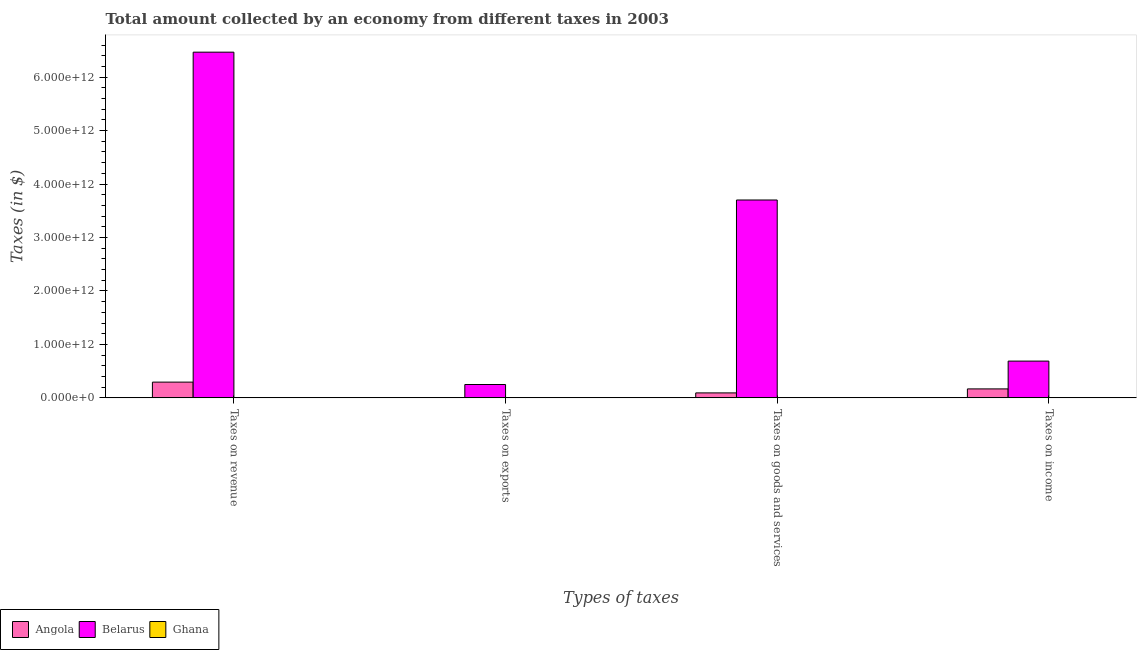How many different coloured bars are there?
Provide a short and direct response. 3. How many groups of bars are there?
Provide a succinct answer. 4. Are the number of bars per tick equal to the number of legend labels?
Provide a short and direct response. Yes. How many bars are there on the 2nd tick from the left?
Ensure brevity in your answer.  3. How many bars are there on the 4th tick from the right?
Offer a terse response. 3. What is the label of the 1st group of bars from the left?
Keep it short and to the point. Taxes on revenue. What is the amount collected as tax on goods in Angola?
Offer a terse response. 9.31e+1. Across all countries, what is the maximum amount collected as tax on income?
Your response must be concise. 6.88e+11. Across all countries, what is the minimum amount collected as tax on exports?
Keep it short and to the point. 7.92e+07. In which country was the amount collected as tax on income maximum?
Your answer should be very brief. Belarus. What is the total amount collected as tax on exports in the graph?
Provide a succinct answer. 2.51e+11. What is the difference between the amount collected as tax on income in Angola and that in Ghana?
Your answer should be very brief. 1.67e+11. What is the difference between the amount collected as tax on income in Belarus and the amount collected as tax on goods in Angola?
Provide a succinct answer. 5.95e+11. What is the average amount collected as tax on income per country?
Give a very brief answer. 2.85e+11. What is the difference between the amount collected as tax on income and amount collected as tax on revenue in Ghana?
Give a very brief answer. -8.66e+08. In how many countries, is the amount collected as tax on exports greater than 4400000000000 $?
Your answer should be compact. 0. What is the ratio of the amount collected as tax on exports in Ghana to that in Angola?
Provide a succinct answer. 0.19. What is the difference between the highest and the second highest amount collected as tax on exports?
Your response must be concise. 2.50e+11. What is the difference between the highest and the lowest amount collected as tax on goods?
Provide a succinct answer. 3.70e+12. In how many countries, is the amount collected as tax on exports greater than the average amount collected as tax on exports taken over all countries?
Offer a terse response. 1. Is the sum of the amount collected as tax on goods in Belarus and Angola greater than the maximum amount collected as tax on exports across all countries?
Ensure brevity in your answer.  Yes. Is it the case that in every country, the sum of the amount collected as tax on revenue and amount collected as tax on income is greater than the sum of amount collected as tax on exports and amount collected as tax on goods?
Your answer should be very brief. No. What does the 1st bar from the left in Taxes on exports represents?
Keep it short and to the point. Angola. What does the 3rd bar from the right in Taxes on goods and services represents?
Keep it short and to the point. Angola. Is it the case that in every country, the sum of the amount collected as tax on revenue and amount collected as tax on exports is greater than the amount collected as tax on goods?
Ensure brevity in your answer.  Yes. How many bars are there?
Offer a very short reply. 12. What is the difference between two consecutive major ticks on the Y-axis?
Give a very brief answer. 1.00e+12. Does the graph contain any zero values?
Offer a very short reply. No. How are the legend labels stacked?
Make the answer very short. Horizontal. What is the title of the graph?
Your response must be concise. Total amount collected by an economy from different taxes in 2003. Does "Lower middle income" appear as one of the legend labels in the graph?
Give a very brief answer. No. What is the label or title of the X-axis?
Give a very brief answer. Types of taxes. What is the label or title of the Y-axis?
Provide a succinct answer. Taxes (in $). What is the Taxes (in $) of Angola in Taxes on revenue?
Offer a very short reply. 2.95e+11. What is the Taxes (in $) in Belarus in Taxes on revenue?
Offer a very short reply. 6.47e+12. What is the Taxes (in $) of Ghana in Taxes on revenue?
Give a very brief answer. 1.22e+09. What is the Taxes (in $) of Angola in Taxes on exports?
Make the answer very short. 4.24e+08. What is the Taxes (in $) of Belarus in Taxes on exports?
Provide a succinct answer. 2.50e+11. What is the Taxes (in $) of Ghana in Taxes on exports?
Make the answer very short. 7.92e+07. What is the Taxes (in $) in Angola in Taxes on goods and services?
Offer a very short reply. 9.31e+1. What is the Taxes (in $) of Belarus in Taxes on goods and services?
Offer a very short reply. 3.70e+12. What is the Taxes (in $) of Ghana in Taxes on goods and services?
Your answer should be compact. 5.50e+08. What is the Taxes (in $) of Angola in Taxes on income?
Provide a succinct answer. 1.68e+11. What is the Taxes (in $) in Belarus in Taxes on income?
Make the answer very short. 6.88e+11. What is the Taxes (in $) in Ghana in Taxes on income?
Keep it short and to the point. 3.57e+08. Across all Types of taxes, what is the maximum Taxes (in $) in Angola?
Give a very brief answer. 2.95e+11. Across all Types of taxes, what is the maximum Taxes (in $) of Belarus?
Give a very brief answer. 6.47e+12. Across all Types of taxes, what is the maximum Taxes (in $) of Ghana?
Your response must be concise. 1.22e+09. Across all Types of taxes, what is the minimum Taxes (in $) of Angola?
Offer a very short reply. 4.24e+08. Across all Types of taxes, what is the minimum Taxes (in $) in Belarus?
Keep it short and to the point. 2.50e+11. Across all Types of taxes, what is the minimum Taxes (in $) of Ghana?
Ensure brevity in your answer.  7.92e+07. What is the total Taxes (in $) of Angola in the graph?
Make the answer very short. 5.56e+11. What is the total Taxes (in $) of Belarus in the graph?
Your response must be concise. 1.11e+13. What is the total Taxes (in $) in Ghana in the graph?
Make the answer very short. 2.21e+09. What is the difference between the Taxes (in $) in Angola in Taxes on revenue and that in Taxes on exports?
Offer a terse response. 2.94e+11. What is the difference between the Taxes (in $) of Belarus in Taxes on revenue and that in Taxes on exports?
Provide a succinct answer. 6.22e+12. What is the difference between the Taxes (in $) of Ghana in Taxes on revenue and that in Taxes on exports?
Provide a succinct answer. 1.14e+09. What is the difference between the Taxes (in $) in Angola in Taxes on revenue and that in Taxes on goods and services?
Make the answer very short. 2.01e+11. What is the difference between the Taxes (in $) in Belarus in Taxes on revenue and that in Taxes on goods and services?
Provide a short and direct response. 2.77e+12. What is the difference between the Taxes (in $) of Ghana in Taxes on revenue and that in Taxes on goods and services?
Make the answer very short. 6.73e+08. What is the difference between the Taxes (in $) of Angola in Taxes on revenue and that in Taxes on income?
Keep it short and to the point. 1.27e+11. What is the difference between the Taxes (in $) in Belarus in Taxes on revenue and that in Taxes on income?
Ensure brevity in your answer.  5.78e+12. What is the difference between the Taxes (in $) in Ghana in Taxes on revenue and that in Taxes on income?
Give a very brief answer. 8.66e+08. What is the difference between the Taxes (in $) of Angola in Taxes on exports and that in Taxes on goods and services?
Make the answer very short. -9.27e+1. What is the difference between the Taxes (in $) of Belarus in Taxes on exports and that in Taxes on goods and services?
Provide a succinct answer. -3.45e+12. What is the difference between the Taxes (in $) in Ghana in Taxes on exports and that in Taxes on goods and services?
Your answer should be compact. -4.70e+08. What is the difference between the Taxes (in $) in Angola in Taxes on exports and that in Taxes on income?
Provide a short and direct response. -1.67e+11. What is the difference between the Taxes (in $) of Belarus in Taxes on exports and that in Taxes on income?
Offer a very short reply. -4.38e+11. What is the difference between the Taxes (in $) of Ghana in Taxes on exports and that in Taxes on income?
Ensure brevity in your answer.  -2.78e+08. What is the difference between the Taxes (in $) of Angola in Taxes on goods and services and that in Taxes on income?
Give a very brief answer. -7.46e+1. What is the difference between the Taxes (in $) of Belarus in Taxes on goods and services and that in Taxes on income?
Your answer should be very brief. 3.01e+12. What is the difference between the Taxes (in $) in Ghana in Taxes on goods and services and that in Taxes on income?
Provide a short and direct response. 1.93e+08. What is the difference between the Taxes (in $) in Angola in Taxes on revenue and the Taxes (in $) in Belarus in Taxes on exports?
Ensure brevity in your answer.  4.45e+1. What is the difference between the Taxes (in $) of Angola in Taxes on revenue and the Taxes (in $) of Ghana in Taxes on exports?
Ensure brevity in your answer.  2.95e+11. What is the difference between the Taxes (in $) in Belarus in Taxes on revenue and the Taxes (in $) in Ghana in Taxes on exports?
Offer a very short reply. 6.47e+12. What is the difference between the Taxes (in $) in Angola in Taxes on revenue and the Taxes (in $) in Belarus in Taxes on goods and services?
Keep it short and to the point. -3.41e+12. What is the difference between the Taxes (in $) in Angola in Taxes on revenue and the Taxes (in $) in Ghana in Taxes on goods and services?
Ensure brevity in your answer.  2.94e+11. What is the difference between the Taxes (in $) of Belarus in Taxes on revenue and the Taxes (in $) of Ghana in Taxes on goods and services?
Offer a terse response. 6.47e+12. What is the difference between the Taxes (in $) of Angola in Taxes on revenue and the Taxes (in $) of Belarus in Taxes on income?
Your answer should be very brief. -3.93e+11. What is the difference between the Taxes (in $) of Angola in Taxes on revenue and the Taxes (in $) of Ghana in Taxes on income?
Ensure brevity in your answer.  2.94e+11. What is the difference between the Taxes (in $) in Belarus in Taxes on revenue and the Taxes (in $) in Ghana in Taxes on income?
Keep it short and to the point. 6.47e+12. What is the difference between the Taxes (in $) in Angola in Taxes on exports and the Taxes (in $) in Belarus in Taxes on goods and services?
Your response must be concise. -3.70e+12. What is the difference between the Taxes (in $) of Angola in Taxes on exports and the Taxes (in $) of Ghana in Taxes on goods and services?
Provide a short and direct response. -1.26e+08. What is the difference between the Taxes (in $) of Belarus in Taxes on exports and the Taxes (in $) of Ghana in Taxes on goods and services?
Provide a succinct answer. 2.50e+11. What is the difference between the Taxes (in $) in Angola in Taxes on exports and the Taxes (in $) in Belarus in Taxes on income?
Offer a very short reply. -6.87e+11. What is the difference between the Taxes (in $) of Angola in Taxes on exports and the Taxes (in $) of Ghana in Taxes on income?
Your answer should be compact. 6.68e+07. What is the difference between the Taxes (in $) of Belarus in Taxes on exports and the Taxes (in $) of Ghana in Taxes on income?
Ensure brevity in your answer.  2.50e+11. What is the difference between the Taxes (in $) in Angola in Taxes on goods and services and the Taxes (in $) in Belarus in Taxes on income?
Provide a succinct answer. -5.95e+11. What is the difference between the Taxes (in $) in Angola in Taxes on goods and services and the Taxes (in $) in Ghana in Taxes on income?
Provide a succinct answer. 9.28e+1. What is the difference between the Taxes (in $) in Belarus in Taxes on goods and services and the Taxes (in $) in Ghana in Taxes on income?
Provide a succinct answer. 3.70e+12. What is the average Taxes (in $) of Angola per Types of taxes?
Keep it short and to the point. 1.39e+11. What is the average Taxes (in $) in Belarus per Types of taxes?
Offer a very short reply. 2.78e+12. What is the average Taxes (in $) in Ghana per Types of taxes?
Give a very brief answer. 5.52e+08. What is the difference between the Taxes (in $) of Angola and Taxes (in $) of Belarus in Taxes on revenue?
Make the answer very short. -6.17e+12. What is the difference between the Taxes (in $) in Angola and Taxes (in $) in Ghana in Taxes on revenue?
Your response must be concise. 2.93e+11. What is the difference between the Taxes (in $) of Belarus and Taxes (in $) of Ghana in Taxes on revenue?
Give a very brief answer. 6.47e+12. What is the difference between the Taxes (in $) in Angola and Taxes (in $) in Belarus in Taxes on exports?
Your response must be concise. -2.50e+11. What is the difference between the Taxes (in $) in Angola and Taxes (in $) in Ghana in Taxes on exports?
Your answer should be very brief. 3.44e+08. What is the difference between the Taxes (in $) in Belarus and Taxes (in $) in Ghana in Taxes on exports?
Provide a short and direct response. 2.50e+11. What is the difference between the Taxes (in $) in Angola and Taxes (in $) in Belarus in Taxes on goods and services?
Give a very brief answer. -3.61e+12. What is the difference between the Taxes (in $) of Angola and Taxes (in $) of Ghana in Taxes on goods and services?
Provide a succinct answer. 9.26e+1. What is the difference between the Taxes (in $) in Belarus and Taxes (in $) in Ghana in Taxes on goods and services?
Your answer should be very brief. 3.70e+12. What is the difference between the Taxes (in $) of Angola and Taxes (in $) of Belarus in Taxes on income?
Ensure brevity in your answer.  -5.20e+11. What is the difference between the Taxes (in $) in Angola and Taxes (in $) in Ghana in Taxes on income?
Keep it short and to the point. 1.67e+11. What is the difference between the Taxes (in $) of Belarus and Taxes (in $) of Ghana in Taxes on income?
Give a very brief answer. 6.87e+11. What is the ratio of the Taxes (in $) of Angola in Taxes on revenue to that in Taxes on exports?
Offer a terse response. 695.46. What is the ratio of the Taxes (in $) in Belarus in Taxes on revenue to that in Taxes on exports?
Your answer should be very brief. 25.86. What is the ratio of the Taxes (in $) in Ghana in Taxes on revenue to that in Taxes on exports?
Your response must be concise. 15.43. What is the ratio of the Taxes (in $) in Angola in Taxes on revenue to that in Taxes on goods and services?
Offer a terse response. 3.16. What is the ratio of the Taxes (in $) of Belarus in Taxes on revenue to that in Taxes on goods and services?
Your answer should be very brief. 1.75. What is the ratio of the Taxes (in $) of Ghana in Taxes on revenue to that in Taxes on goods and services?
Provide a succinct answer. 2.22. What is the ratio of the Taxes (in $) in Angola in Taxes on revenue to that in Taxes on income?
Provide a short and direct response. 1.76. What is the ratio of the Taxes (in $) of Belarus in Taxes on revenue to that in Taxes on income?
Your answer should be very brief. 9.4. What is the ratio of the Taxes (in $) of Ghana in Taxes on revenue to that in Taxes on income?
Offer a very short reply. 3.43. What is the ratio of the Taxes (in $) in Angola in Taxes on exports to that in Taxes on goods and services?
Offer a very short reply. 0. What is the ratio of the Taxes (in $) of Belarus in Taxes on exports to that in Taxes on goods and services?
Ensure brevity in your answer.  0.07. What is the ratio of the Taxes (in $) in Ghana in Taxes on exports to that in Taxes on goods and services?
Ensure brevity in your answer.  0.14. What is the ratio of the Taxes (in $) of Angola in Taxes on exports to that in Taxes on income?
Provide a short and direct response. 0. What is the ratio of the Taxes (in $) in Belarus in Taxes on exports to that in Taxes on income?
Ensure brevity in your answer.  0.36. What is the ratio of the Taxes (in $) in Ghana in Taxes on exports to that in Taxes on income?
Offer a terse response. 0.22. What is the ratio of the Taxes (in $) of Angola in Taxes on goods and services to that in Taxes on income?
Make the answer very short. 0.56. What is the ratio of the Taxes (in $) in Belarus in Taxes on goods and services to that in Taxes on income?
Keep it short and to the point. 5.38. What is the ratio of the Taxes (in $) of Ghana in Taxes on goods and services to that in Taxes on income?
Your answer should be compact. 1.54. What is the difference between the highest and the second highest Taxes (in $) in Angola?
Your response must be concise. 1.27e+11. What is the difference between the highest and the second highest Taxes (in $) of Belarus?
Your response must be concise. 2.77e+12. What is the difference between the highest and the second highest Taxes (in $) in Ghana?
Offer a terse response. 6.73e+08. What is the difference between the highest and the lowest Taxes (in $) of Angola?
Ensure brevity in your answer.  2.94e+11. What is the difference between the highest and the lowest Taxes (in $) of Belarus?
Provide a succinct answer. 6.22e+12. What is the difference between the highest and the lowest Taxes (in $) in Ghana?
Keep it short and to the point. 1.14e+09. 